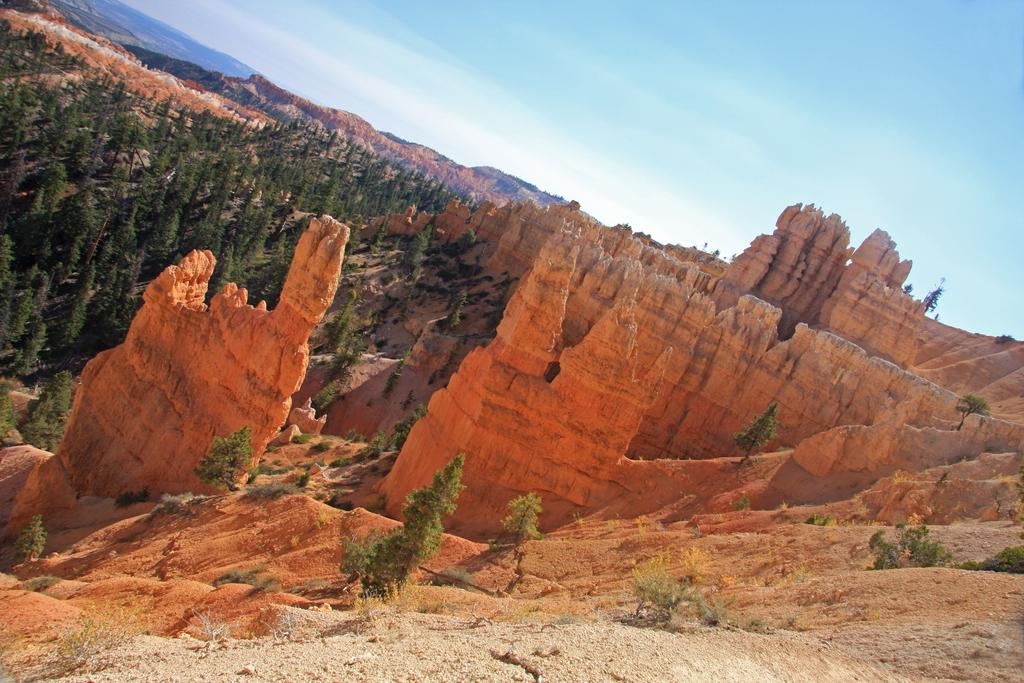What is the setting of the image? The image has an outside view. What can be seen in the foreground of the image? There are trees and hills in the foreground of the image. What is visible in the background of the image? The sky is visible in the background of the image. What month is it in the image? The month cannot be determined from the image, as there is no information about the time of year. Can you see a cub in the image? There is no cub present in the image. 